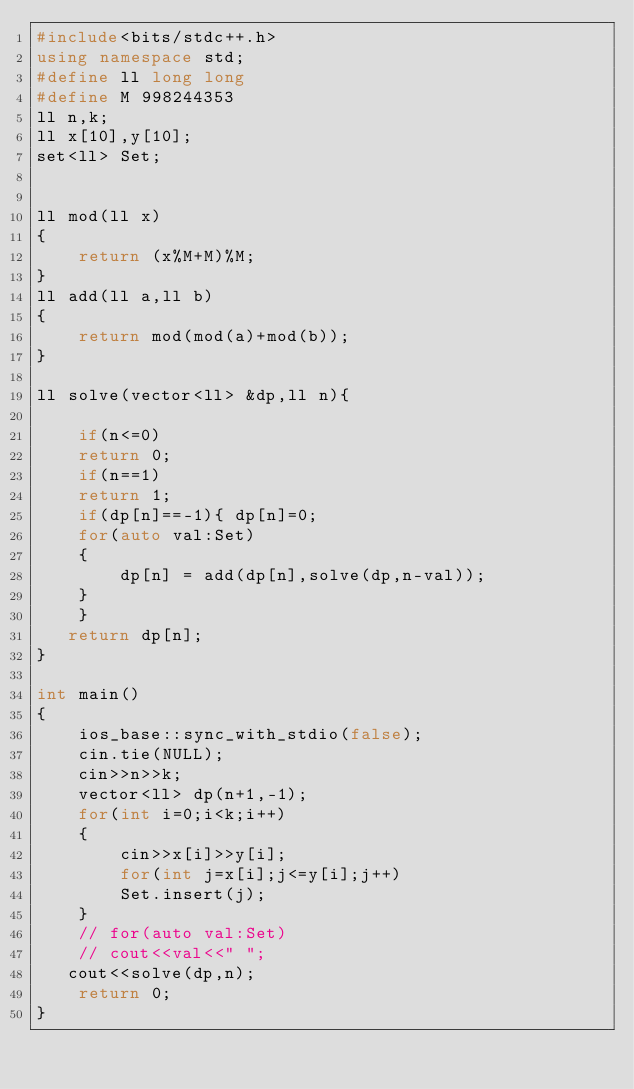<code> <loc_0><loc_0><loc_500><loc_500><_C++_>#include<bits/stdc++.h>
using namespace std;
#define ll long long
#define M 998244353
ll n,k;
ll x[10],y[10];
set<ll> Set;


ll mod(ll x)
{
    return (x%M+M)%M;
}
ll add(ll a,ll b)
{
    return mod(mod(a)+mod(b));
}

ll solve(vector<ll> &dp,ll n){

    if(n<=0)
    return 0;
    if(n==1)
    return 1;
    if(dp[n]==-1){ dp[n]=0;
    for(auto val:Set)
    {
        dp[n] = add(dp[n],solve(dp,n-val));
    }    
    }
   return dp[n];
}

int main()
{
    ios_base::sync_with_stdio(false);
    cin.tie(NULL);
    cin>>n>>k;
    vector<ll> dp(n+1,-1);
    for(int i=0;i<k;i++)
    {
        cin>>x[i]>>y[i];
        for(int j=x[i];j<=y[i];j++)
        Set.insert(j);
    }
    // for(auto val:Set)
    // cout<<val<<" "; 
   cout<<solve(dp,n);
    return 0;
}</code> 